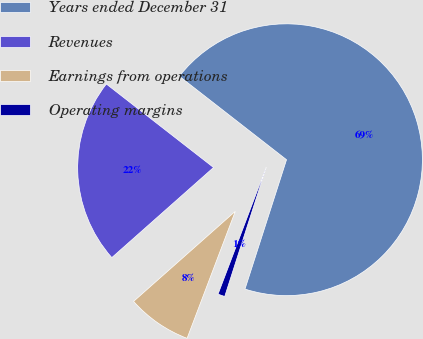Convert chart. <chart><loc_0><loc_0><loc_500><loc_500><pie_chart><fcel>Years ended December 31<fcel>Revenues<fcel>Earnings from operations<fcel>Operating margins<nl><fcel>69.42%<fcel>22.07%<fcel>7.69%<fcel>0.83%<nl></chart> 